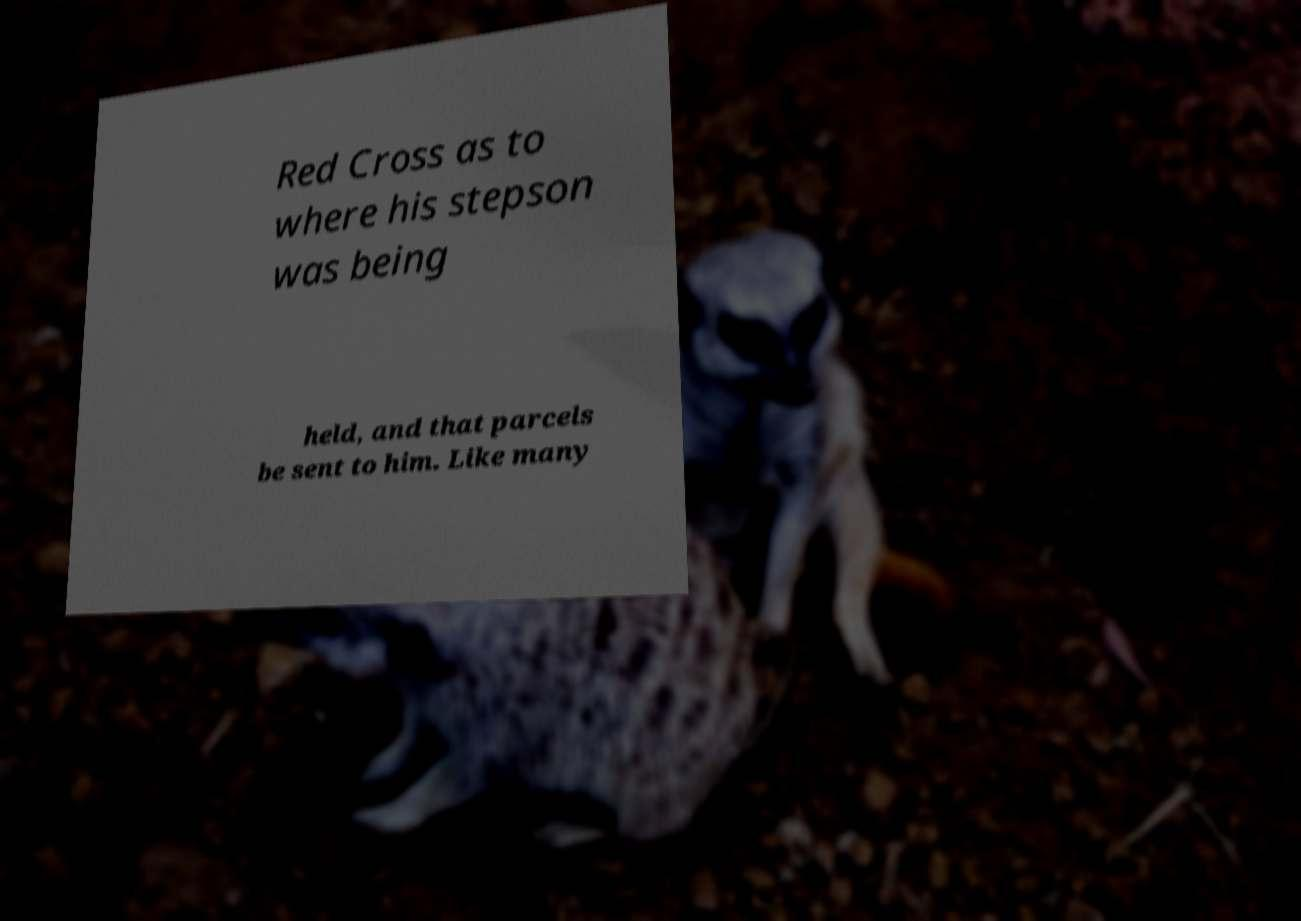Please read and relay the text visible in this image. What does it say? Red Cross as to where his stepson was being held, and that parcels be sent to him. Like many 